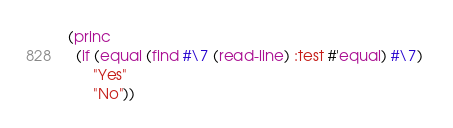<code> <loc_0><loc_0><loc_500><loc_500><_Lisp_>(princ 
  (if (equal (find #\7 (read-line) :test #'equal) #\7) 
      "Yes" 
      "No"))
</code> 